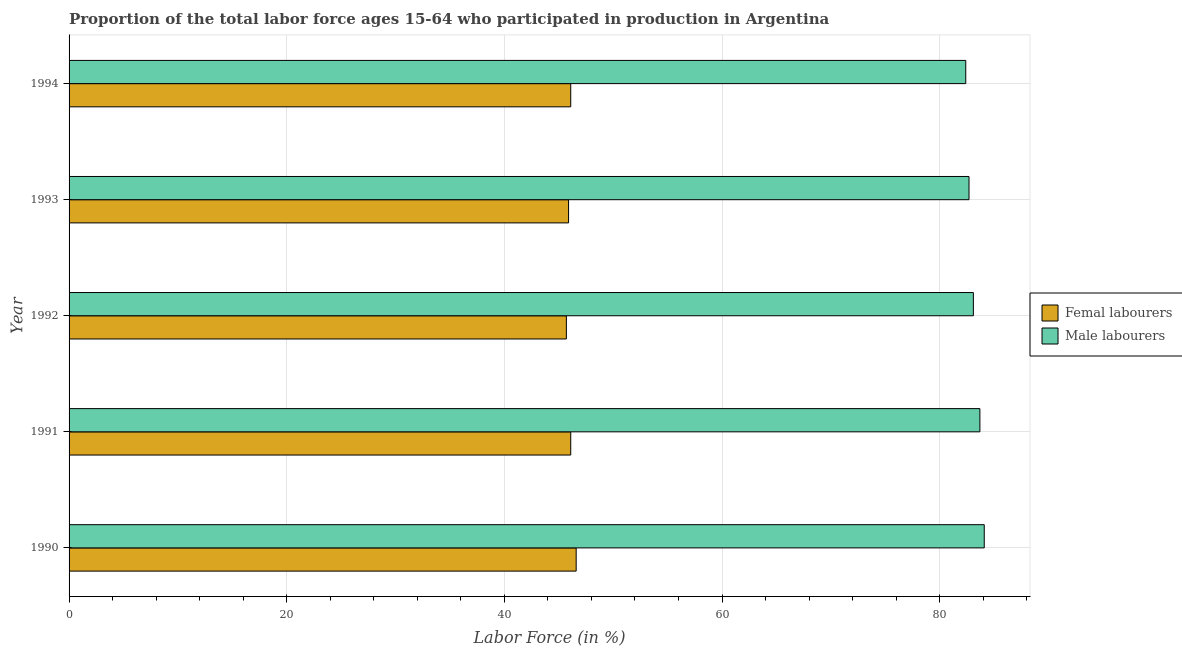Are the number of bars per tick equal to the number of legend labels?
Your answer should be compact. Yes. What is the percentage of male labour force in 1992?
Your answer should be very brief. 83.1. Across all years, what is the maximum percentage of male labour force?
Your answer should be very brief. 84.1. Across all years, what is the minimum percentage of female labor force?
Give a very brief answer. 45.7. In which year was the percentage of male labour force maximum?
Your answer should be compact. 1990. In which year was the percentage of male labour force minimum?
Provide a short and direct response. 1994. What is the total percentage of female labor force in the graph?
Provide a short and direct response. 230.4. What is the difference between the percentage of female labor force in 1994 and the percentage of male labour force in 1990?
Offer a terse response. -38. What is the average percentage of female labor force per year?
Offer a very short reply. 46.08. In the year 1992, what is the difference between the percentage of female labor force and percentage of male labour force?
Your answer should be very brief. -37.4. What is the ratio of the percentage of male labour force in 1992 to that in 1994?
Provide a succinct answer. 1.01. Is the percentage of female labor force in 1991 less than that in 1993?
Provide a succinct answer. No. What is the difference between the highest and the second highest percentage of male labour force?
Your answer should be very brief. 0.4. What is the difference between the highest and the lowest percentage of male labour force?
Provide a succinct answer. 1.7. In how many years, is the percentage of female labor force greater than the average percentage of female labor force taken over all years?
Keep it short and to the point. 3. Is the sum of the percentage of male labour force in 1990 and 1993 greater than the maximum percentage of female labor force across all years?
Your response must be concise. Yes. What does the 2nd bar from the top in 1993 represents?
Make the answer very short. Femal labourers. What does the 1st bar from the bottom in 1993 represents?
Provide a succinct answer. Femal labourers. How many bars are there?
Your answer should be very brief. 10. Are all the bars in the graph horizontal?
Make the answer very short. Yes. What is the difference between two consecutive major ticks on the X-axis?
Give a very brief answer. 20. Does the graph contain grids?
Your answer should be very brief. Yes. Where does the legend appear in the graph?
Your response must be concise. Center right. How are the legend labels stacked?
Provide a short and direct response. Vertical. What is the title of the graph?
Your response must be concise. Proportion of the total labor force ages 15-64 who participated in production in Argentina. What is the label or title of the X-axis?
Your answer should be compact. Labor Force (in %). What is the label or title of the Y-axis?
Give a very brief answer. Year. What is the Labor Force (in %) of Femal labourers in 1990?
Ensure brevity in your answer.  46.6. What is the Labor Force (in %) in Male labourers in 1990?
Offer a very short reply. 84.1. What is the Labor Force (in %) in Femal labourers in 1991?
Make the answer very short. 46.1. What is the Labor Force (in %) in Male labourers in 1991?
Give a very brief answer. 83.7. What is the Labor Force (in %) of Femal labourers in 1992?
Your response must be concise. 45.7. What is the Labor Force (in %) in Male labourers in 1992?
Provide a succinct answer. 83.1. What is the Labor Force (in %) in Femal labourers in 1993?
Offer a very short reply. 45.9. What is the Labor Force (in %) of Male labourers in 1993?
Provide a short and direct response. 82.7. What is the Labor Force (in %) of Femal labourers in 1994?
Your response must be concise. 46.1. What is the Labor Force (in %) of Male labourers in 1994?
Keep it short and to the point. 82.4. Across all years, what is the maximum Labor Force (in %) in Femal labourers?
Offer a very short reply. 46.6. Across all years, what is the maximum Labor Force (in %) of Male labourers?
Your answer should be compact. 84.1. Across all years, what is the minimum Labor Force (in %) of Femal labourers?
Provide a short and direct response. 45.7. Across all years, what is the minimum Labor Force (in %) in Male labourers?
Your answer should be compact. 82.4. What is the total Labor Force (in %) in Femal labourers in the graph?
Your answer should be very brief. 230.4. What is the total Labor Force (in %) of Male labourers in the graph?
Your answer should be compact. 416. What is the difference between the Labor Force (in %) in Male labourers in 1990 and that in 1991?
Your answer should be compact. 0.4. What is the difference between the Labor Force (in %) of Male labourers in 1990 and that in 1992?
Offer a very short reply. 1. What is the difference between the Labor Force (in %) of Male labourers in 1990 and that in 1994?
Your answer should be very brief. 1.7. What is the difference between the Labor Force (in %) of Male labourers in 1991 and that in 1992?
Give a very brief answer. 0.6. What is the difference between the Labor Force (in %) in Male labourers in 1991 and that in 1993?
Offer a very short reply. 1. What is the difference between the Labor Force (in %) in Femal labourers in 1991 and that in 1994?
Your answer should be very brief. 0. What is the difference between the Labor Force (in %) of Male labourers in 1991 and that in 1994?
Offer a very short reply. 1.3. What is the difference between the Labor Force (in %) in Femal labourers in 1992 and that in 1994?
Your answer should be very brief. -0.4. What is the difference between the Labor Force (in %) in Male labourers in 1992 and that in 1994?
Ensure brevity in your answer.  0.7. What is the difference between the Labor Force (in %) in Femal labourers in 1990 and the Labor Force (in %) in Male labourers in 1991?
Make the answer very short. -37.1. What is the difference between the Labor Force (in %) of Femal labourers in 1990 and the Labor Force (in %) of Male labourers in 1992?
Provide a short and direct response. -36.5. What is the difference between the Labor Force (in %) in Femal labourers in 1990 and the Labor Force (in %) in Male labourers in 1993?
Your response must be concise. -36.1. What is the difference between the Labor Force (in %) of Femal labourers in 1990 and the Labor Force (in %) of Male labourers in 1994?
Offer a very short reply. -35.8. What is the difference between the Labor Force (in %) in Femal labourers in 1991 and the Labor Force (in %) in Male labourers in 1992?
Provide a short and direct response. -37. What is the difference between the Labor Force (in %) in Femal labourers in 1991 and the Labor Force (in %) in Male labourers in 1993?
Offer a very short reply. -36.6. What is the difference between the Labor Force (in %) of Femal labourers in 1991 and the Labor Force (in %) of Male labourers in 1994?
Your answer should be compact. -36.3. What is the difference between the Labor Force (in %) in Femal labourers in 1992 and the Labor Force (in %) in Male labourers in 1993?
Your answer should be very brief. -37. What is the difference between the Labor Force (in %) in Femal labourers in 1992 and the Labor Force (in %) in Male labourers in 1994?
Your answer should be compact. -36.7. What is the difference between the Labor Force (in %) in Femal labourers in 1993 and the Labor Force (in %) in Male labourers in 1994?
Ensure brevity in your answer.  -36.5. What is the average Labor Force (in %) in Femal labourers per year?
Provide a short and direct response. 46.08. What is the average Labor Force (in %) in Male labourers per year?
Provide a short and direct response. 83.2. In the year 1990, what is the difference between the Labor Force (in %) in Femal labourers and Labor Force (in %) in Male labourers?
Provide a succinct answer. -37.5. In the year 1991, what is the difference between the Labor Force (in %) of Femal labourers and Labor Force (in %) of Male labourers?
Offer a very short reply. -37.6. In the year 1992, what is the difference between the Labor Force (in %) of Femal labourers and Labor Force (in %) of Male labourers?
Make the answer very short. -37.4. In the year 1993, what is the difference between the Labor Force (in %) in Femal labourers and Labor Force (in %) in Male labourers?
Provide a short and direct response. -36.8. In the year 1994, what is the difference between the Labor Force (in %) of Femal labourers and Labor Force (in %) of Male labourers?
Offer a terse response. -36.3. What is the ratio of the Labor Force (in %) of Femal labourers in 1990 to that in 1991?
Your answer should be very brief. 1.01. What is the ratio of the Labor Force (in %) in Male labourers in 1990 to that in 1991?
Your answer should be very brief. 1. What is the ratio of the Labor Force (in %) of Femal labourers in 1990 to that in 1992?
Ensure brevity in your answer.  1.02. What is the ratio of the Labor Force (in %) in Femal labourers in 1990 to that in 1993?
Your response must be concise. 1.02. What is the ratio of the Labor Force (in %) of Male labourers in 1990 to that in 1993?
Provide a succinct answer. 1.02. What is the ratio of the Labor Force (in %) of Femal labourers in 1990 to that in 1994?
Keep it short and to the point. 1.01. What is the ratio of the Labor Force (in %) of Male labourers in 1990 to that in 1994?
Provide a short and direct response. 1.02. What is the ratio of the Labor Force (in %) in Femal labourers in 1991 to that in 1992?
Offer a very short reply. 1.01. What is the ratio of the Labor Force (in %) of Male labourers in 1991 to that in 1993?
Your answer should be compact. 1.01. What is the ratio of the Labor Force (in %) in Femal labourers in 1991 to that in 1994?
Your response must be concise. 1. What is the ratio of the Labor Force (in %) of Male labourers in 1991 to that in 1994?
Keep it short and to the point. 1.02. What is the ratio of the Labor Force (in %) of Femal labourers in 1992 to that in 1993?
Ensure brevity in your answer.  1. What is the ratio of the Labor Force (in %) in Femal labourers in 1992 to that in 1994?
Your answer should be compact. 0.99. What is the ratio of the Labor Force (in %) in Male labourers in 1992 to that in 1994?
Your answer should be compact. 1.01. What is the difference between the highest and the second highest Labor Force (in %) in Femal labourers?
Your response must be concise. 0.5. What is the difference between the highest and the second highest Labor Force (in %) of Male labourers?
Provide a short and direct response. 0.4. What is the difference between the highest and the lowest Labor Force (in %) in Male labourers?
Your answer should be compact. 1.7. 